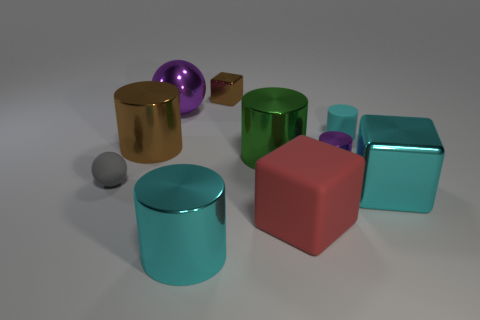How many objects are there, and can you describe their colors and shapes? There are nine objects in the image. Starting from the left, there's a small gray sphere, a golden cylindrical object with a cut-out, a purple reflective sphere, a small brown cube, a green cylindrical object, a smaller purple cube, a large cyan cube, a red cube with rounded edges, and a cyan cylinder. Each object showcases different geometric shapes like spheres, cubes, and cylinders, as well as a variety of colors like gray, gold, purple, brown, green, red, and shades of cyan. 